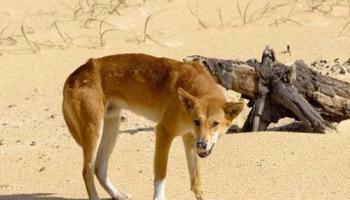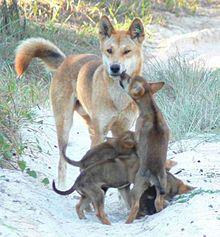The first image is the image on the left, the second image is the image on the right. Given the left and right images, does the statement "The right image features a single dog posed outdoors facing forwards." hold true? Answer yes or no. No. 